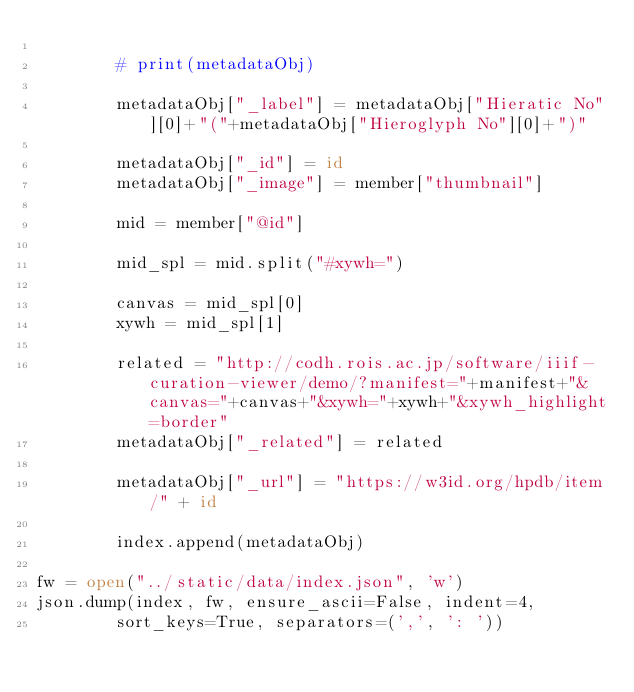Convert code to text. <code><loc_0><loc_0><loc_500><loc_500><_Python_>
        # print(metadataObj)

        metadataObj["_label"] = metadataObj["Hieratic No"][0]+"("+metadataObj["Hieroglyph No"][0]+")"

        metadataObj["_id"] = id
        metadataObj["_image"] = member["thumbnail"]

        mid = member["@id"]

        mid_spl = mid.split("#xywh=")

        canvas = mid_spl[0]
        xywh = mid_spl[1]

        related = "http://codh.rois.ac.jp/software/iiif-curation-viewer/demo/?manifest="+manifest+"&canvas="+canvas+"&xywh="+xywh+"&xywh_highlight=border"
        metadataObj["_related"] = related

        metadataObj["_url"] = "https://w3id.org/hpdb/item/" + id

        index.append(metadataObj)

fw = open("../static/data/index.json", 'w')
json.dump(index, fw, ensure_ascii=False, indent=4,
        sort_keys=True, separators=(',', ': '))</code> 